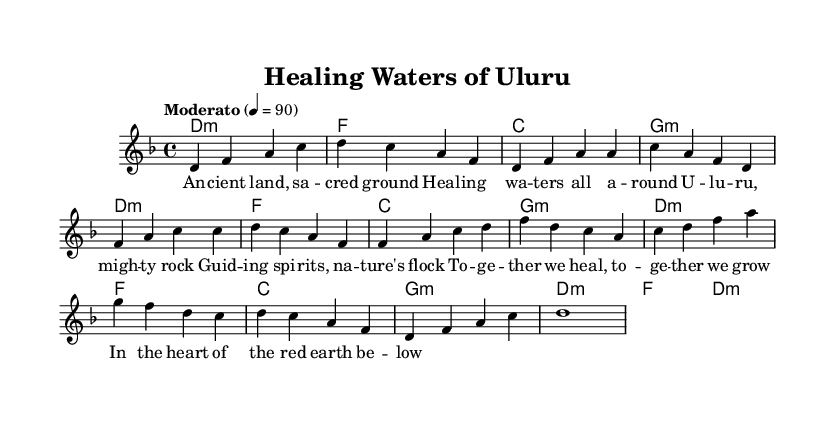What is the key signature of this music? The key signature is D minor, indicated by one flat (B♭) on the staff.
Answer: D minor What is the time signature of this music? The time signature is 4/4, which is shown at the beginning of the sheet music, indicating four beats per measure.
Answer: 4/4 What is the tempo marking given for this piece? The tempo marking is "Moderato", which indicates a moderate speed, and the number 4 = 90 shows the beats per minute.
Answer: Moderato How many measures are in the verse section of the music? The verse consists of four measures as indicated by the grouping of notes in that section.
Answer: 4 What are the themes represented in the lyrics? The lyrics express themes of healing and community, evident through phrases such as "healing waters" and "together we heal."
Answer: Healing and community Which chord is played on the first measure? The first measure contains the chord D minor, as indicated in the chord names section above the staff.
Answer: D minor What is the last chord played in the piece? The last chord is D minor, as seen in the final measure.
Answer: D minor 